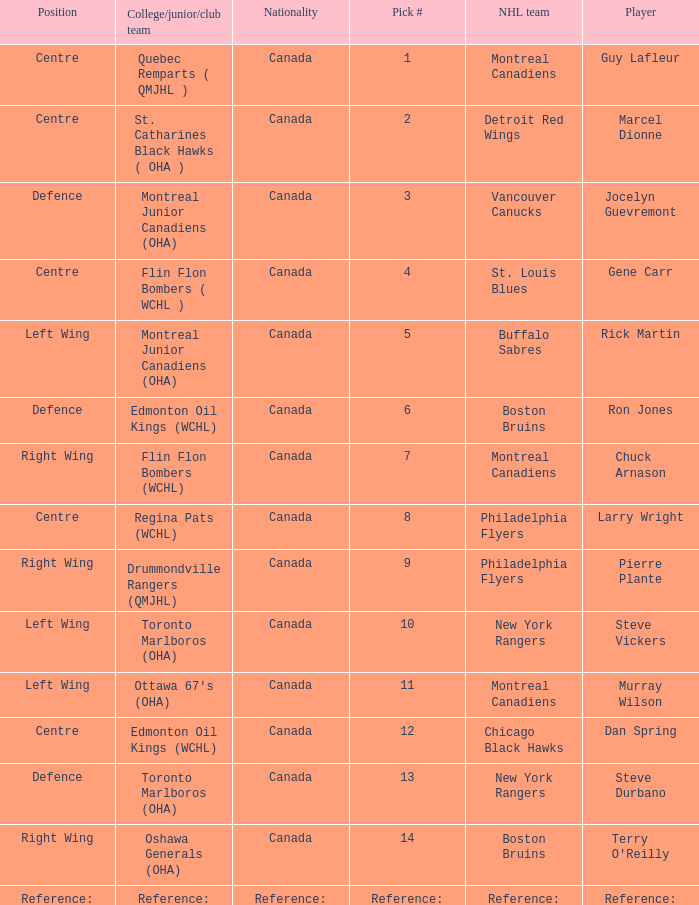Which College/junior/club team has a Pick # of 1? Quebec Remparts ( QMJHL ). 